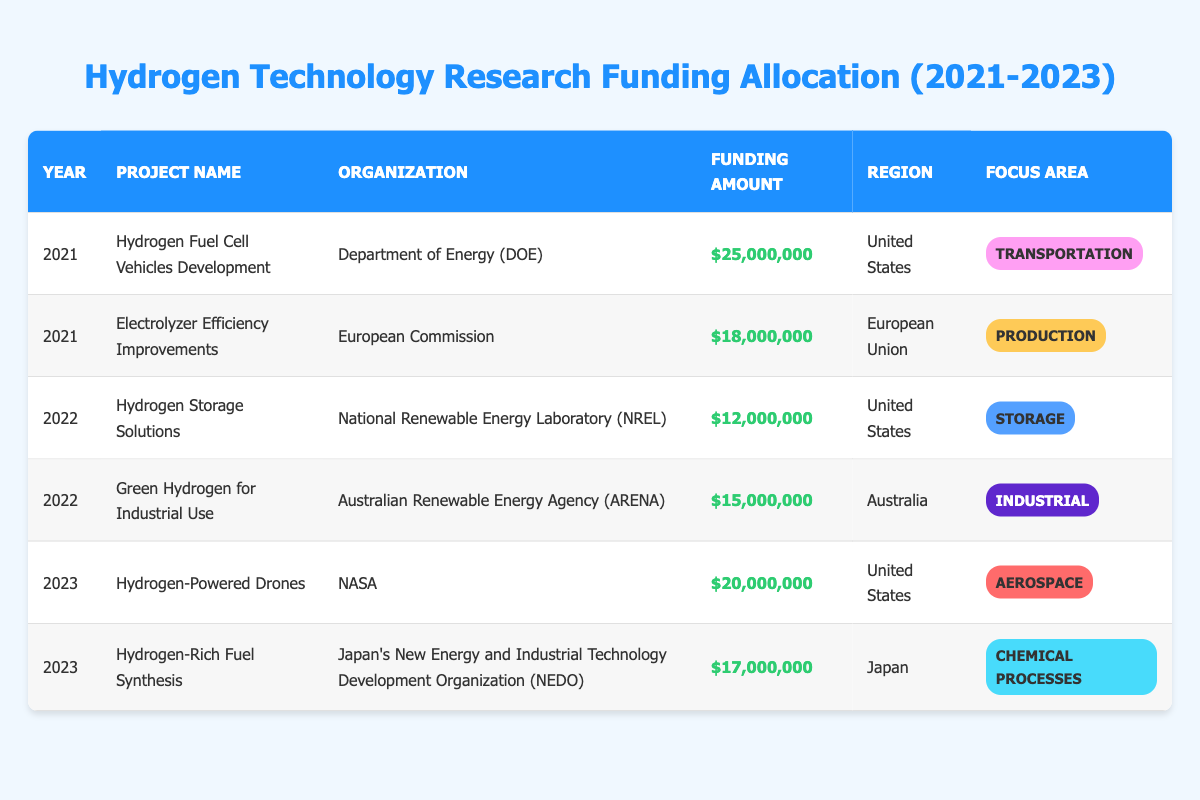What is the total funding amount allocated for hydrogen projects in 2022? In 2022, there are two projects listed: "Hydrogen Storage Solutions" with a funding amount of 12,000,000 and "Green Hydrogen for Industrial Use" with 15,000,000. Summing these amounts gives: 12,000,000 + 15,000,000 = 27,000,000.
Answer: 27,000,000 Which organization received the highest funding in 2021? In 2021, the organization "Department of Energy (DOE)" received 25,000,000 for the project "Hydrogen Fuel Cell Vehicles Development". The other organization, "European Commission", received 18,000,000. Therefore, DOE received the highest funding in that year.
Answer: Department of Energy (DOE) Is there any project for hydrogen technology funding in Australia for 2023? The table lists projects for 2023, and "Hydrogen-Rich Fuel Synthesis" is associated with Japan while "Hydrogen-Powered Drones" is for the United States. Thus, there are no projects listed for Australia in 2023.
Answer: No What is the average funding amount allocated for hydrogen projects over the three years? To find the average, first, calculate the total funding across all years: 25,000,000 + 18,000,000 + 12,000,000 + 15,000,000 + 20,000,000 + 17,000,000 = 107,000,000. There are six projects, so the average is 107,000,000 / 6 = 17,833,333.33.
Answer: 17,833,333.33 Was there any project focused on "Storage" filed under the European Union in 2021? In the table, the project "Electrolyzer Efficiency Improvements" under the European Commission focuses on "Production", not "Storage". The 2021 storage project was "Hydrogen Storage Solutions", which is under the United States. Therefore, the answer is no.
Answer: No How much funding did projects focusing on "Industrial" receive in total? There is one project named "Green Hydrogen for Industrial Use" in the "Industrial" category with a funding amount of 15,000,000. Thus, the total funding for projects focused on "Industrial" is simply 15,000,000.
Answer: 15,000,000 Which region had the largest single project funding in 2023? In 2023, two projects are listed: "Hydrogen-Powered Drones" for the United States at 20,000,000 and "Hydrogen-Rich Fuel Synthesis" for Japan at 17,000,000. The project in the United States received the largest single funding amount.
Answer: United States What focus area received the second highest funding in 2021? In 2021, the focus areas and their respective funding amounts are: "Transportation" with 25,000,000 and "Production" with 18,000,000. Since "Production" has the second highest amount, the answer relates to that area.
Answer: Production 